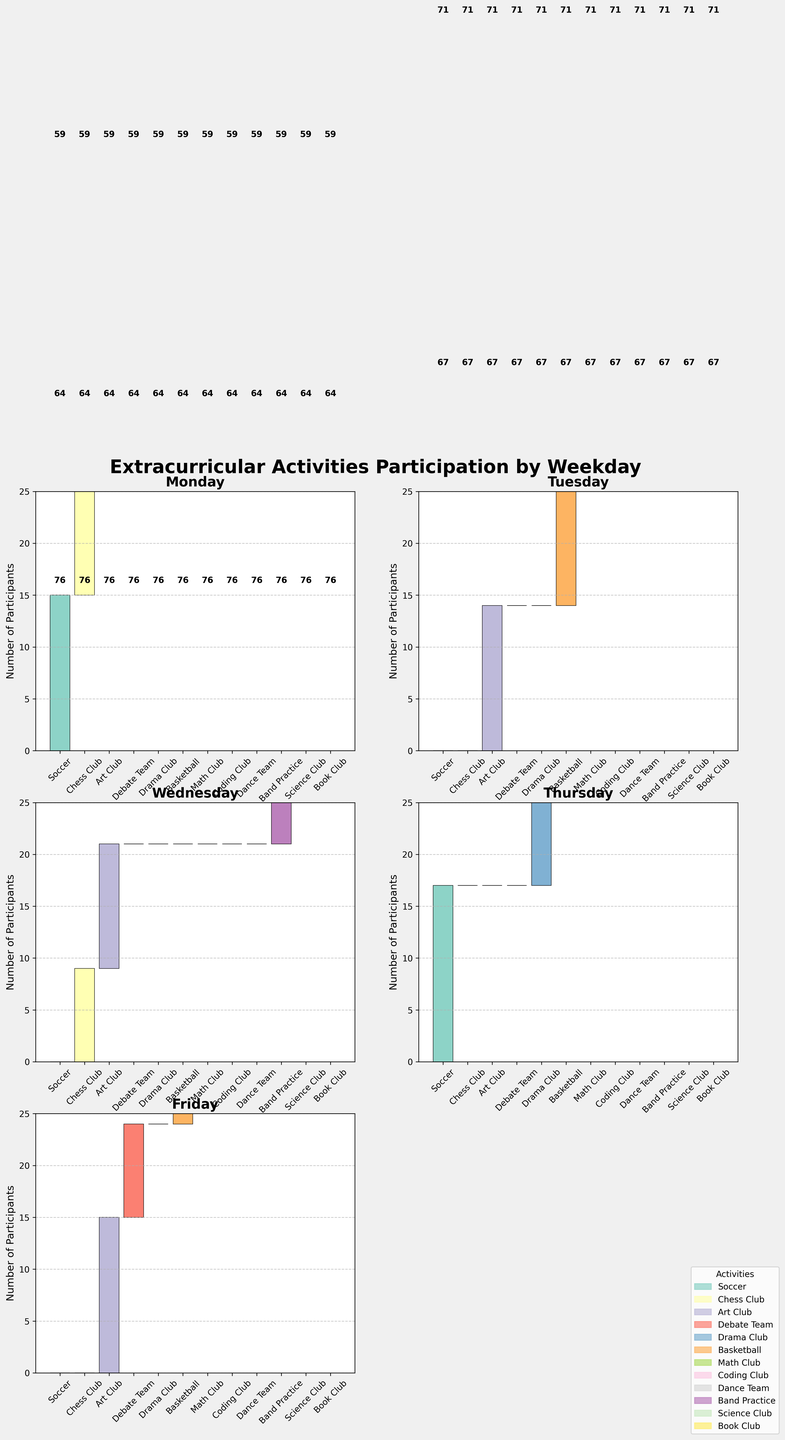what is the title of the figure? The title is usually placed at the top of the figure. By looking at the top of the figure, we can see the title "Extracurricular Activities Participation by Weekday."
Answer: Extracurricular Activities Participation by Weekday How many participants does the Band Practice activity have on Wednesday? By looking at the Wednesday subplot, identify the Band Practice bar and find the corresponding value. The number next to the bar indicates 20 participants.
Answer: 20 Which activity has the highest number of participants on Tuesday? To determine this, examine the Tuesday subplot and compare the heights of all bars. Basketball has the tallest bar, indicating the highest number of participants, which is 18.
Answer: Basketball What is the total number of activities on Monday? By counting the distinct bars in the Monday subplot, we see five activities: Soccer, Chess Club, Art Club, Debate Team, and Drama Club.
Answer: 5 Which day has the Art Club activity with the most participants, and how many are there? Compare the number of participants for the Art Club across all days. On Tuesday, Art Club has 14 participants, which is the highest for this activity across the days.
Answer: Tuesday, 14 How many more participants are there in Dance Team on Thursday compared to Drama Club on the same day? On Thursday, Dance Team has 15 participants and Drama Club has 13 participants. Subtract 13 from 15 to get the difference.
Answer: 2 What is the average number of participants for Chess Club across the days it is offered? Chess Club is offered on Monday (10 participants) and Wednesday (9 participants). Calculate the average: (10 + 9) / 2 = 9.5.
Answer: 9.5 Is there any day where Coding Club and Math Club both have participants? Examine each subplot and look for days with both Coding Club and Math Club bars. Only Tuesday and Thursday have both activities marked with participant numbers for each.
Answer: Yes, Tuesday and Thursday Which activity is only observed on a single day, and which day is it? Look for activities that appear on only one subplot. For example, Book Club only appears on Wednesday.
Answer: Book Club, Wednesday What is the sum of participants for all activities on Friday? Add the number of participants for each activity on Friday: Basketball (20), Science Club (14), Debate Team (9), Art Club (15), and Band Practice (18). The sum is 20 + 14 + 9 + 15 + 18 = 76.
Answer: 76 